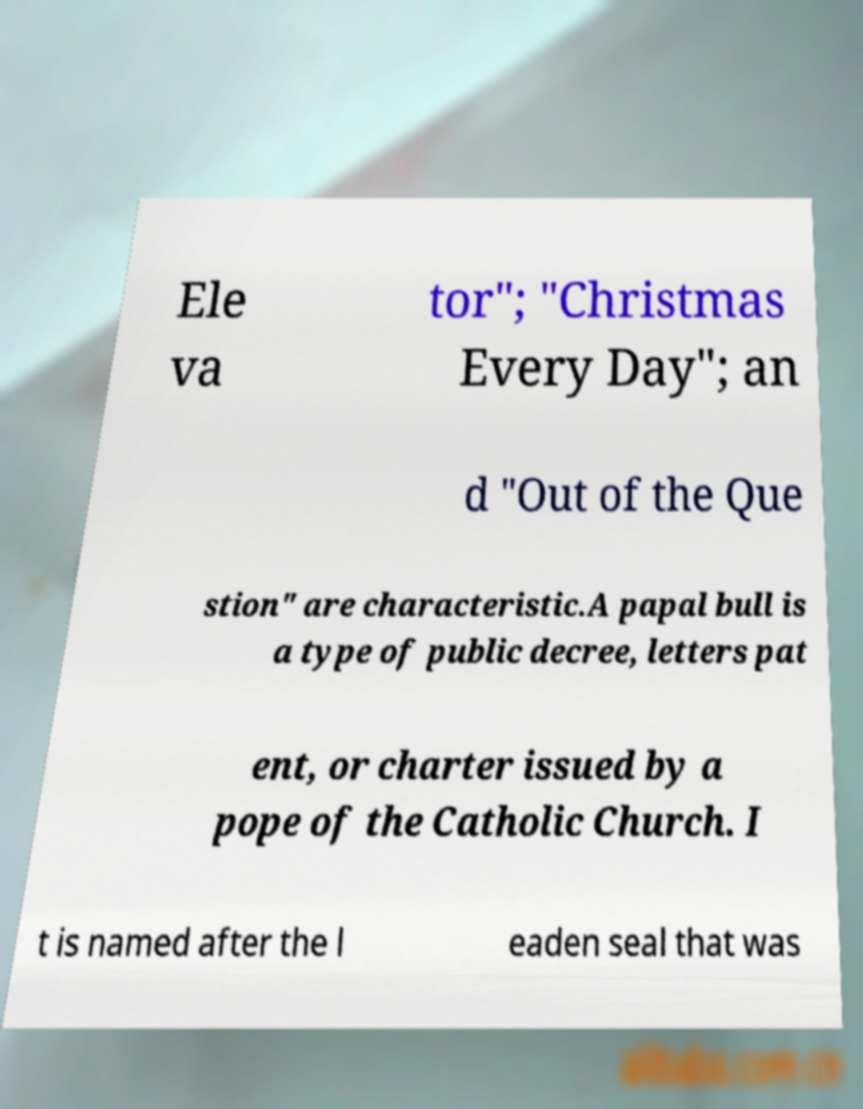Can you accurately transcribe the text from the provided image for me? Ele va tor"; "Christmas Every Day"; an d "Out of the Que stion" are characteristic.A papal bull is a type of public decree, letters pat ent, or charter issued by a pope of the Catholic Church. I t is named after the l eaden seal that was 